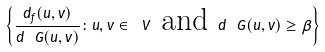<formula> <loc_0><loc_0><loc_500><loc_500>\left \{ \frac { d _ { f } ( u , v ) } { d _ { \ } G ( u , v ) } \colon u , v \in \ V \text { and } d _ { \ } G ( u , v ) \geq \beta \right \}</formula> 